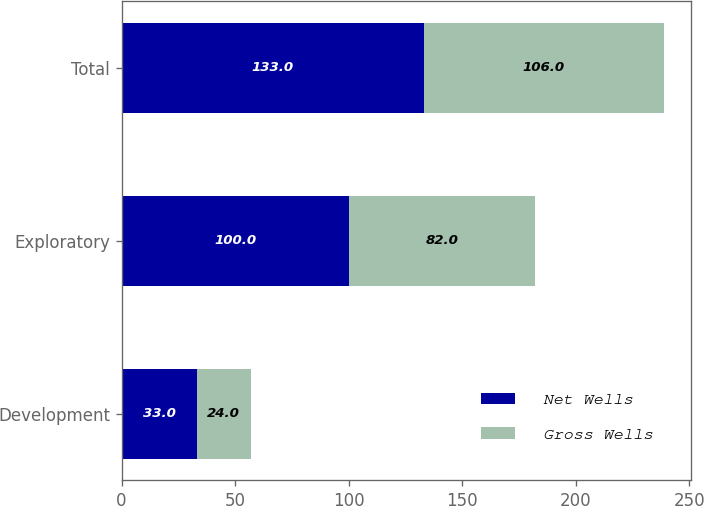Convert chart. <chart><loc_0><loc_0><loc_500><loc_500><stacked_bar_chart><ecel><fcel>Development<fcel>Exploratory<fcel>Total<nl><fcel>Net Wells<fcel>33<fcel>100<fcel>133<nl><fcel>Gross Wells<fcel>24<fcel>82<fcel>106<nl></chart> 